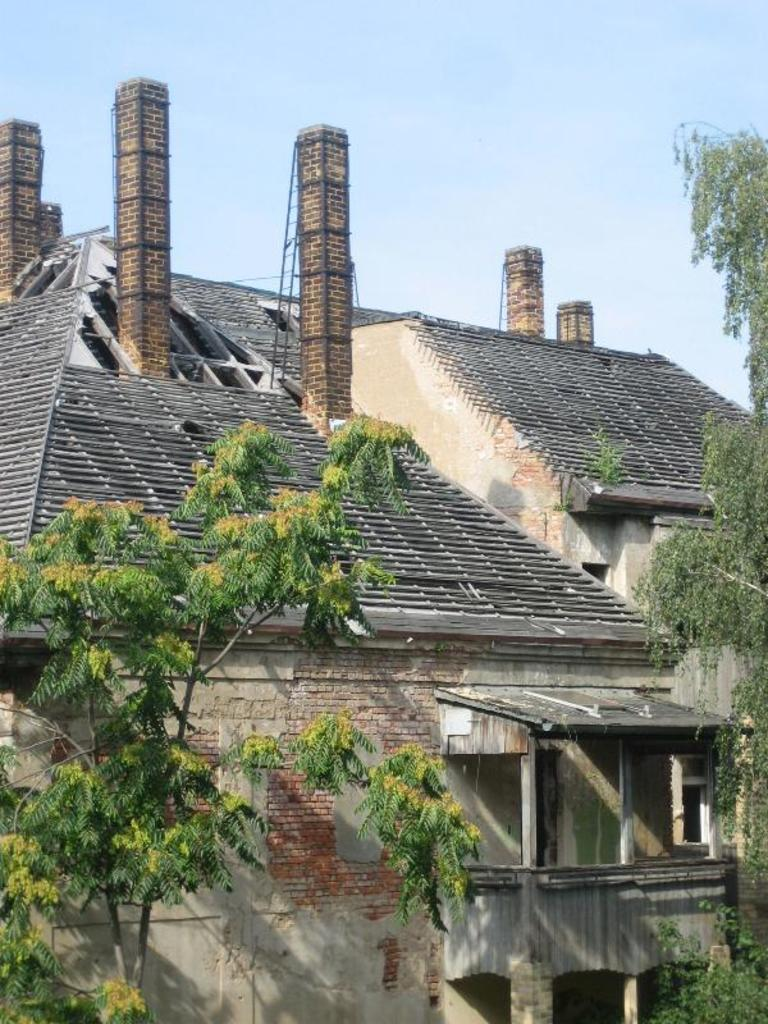What type of structure is visible in the image? There is a building in the image. What can be seen on the right side of the image? There are trees on the right side of the image. What can be seen on the left side of the image? There are trees on the left side of the image. What type of cream is used to create the texture of the building in the image? There is no mention of cream or texture in relation to the building in the image. The building is likely made of traditional materials like brick, concrete, or wood. 